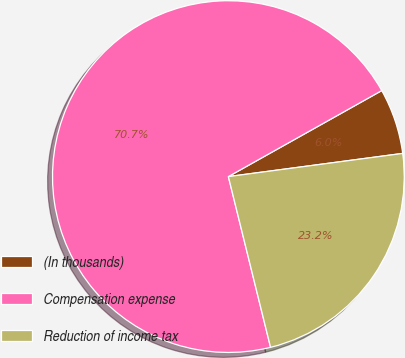Convert chart. <chart><loc_0><loc_0><loc_500><loc_500><pie_chart><fcel>(In thousands)<fcel>Compensation expense<fcel>Reduction of income tax<nl><fcel>6.03%<fcel>70.73%<fcel>23.25%<nl></chart> 